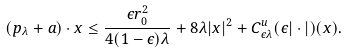Convert formula to latex. <formula><loc_0><loc_0><loc_500><loc_500>( p _ { \lambda } + a ) \cdot x \leq \frac { \epsilon r _ { 0 } ^ { 2 } } { 4 ( 1 - \epsilon ) \lambda } + 8 \lambda | x | ^ { 2 } + C ^ { u } _ { \epsilon \lambda } ( \epsilon | \cdot | ) ( x ) .</formula> 